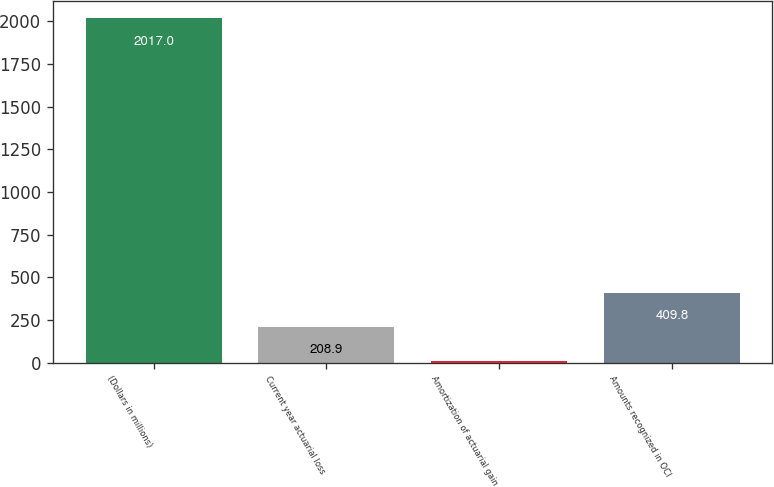Convert chart to OTSL. <chart><loc_0><loc_0><loc_500><loc_500><bar_chart><fcel>(Dollars in millions)<fcel>Current year actuarial loss<fcel>Amortization of actuarial gain<fcel>Amounts recognized in OCI<nl><fcel>2017<fcel>208.9<fcel>8<fcel>409.8<nl></chart> 